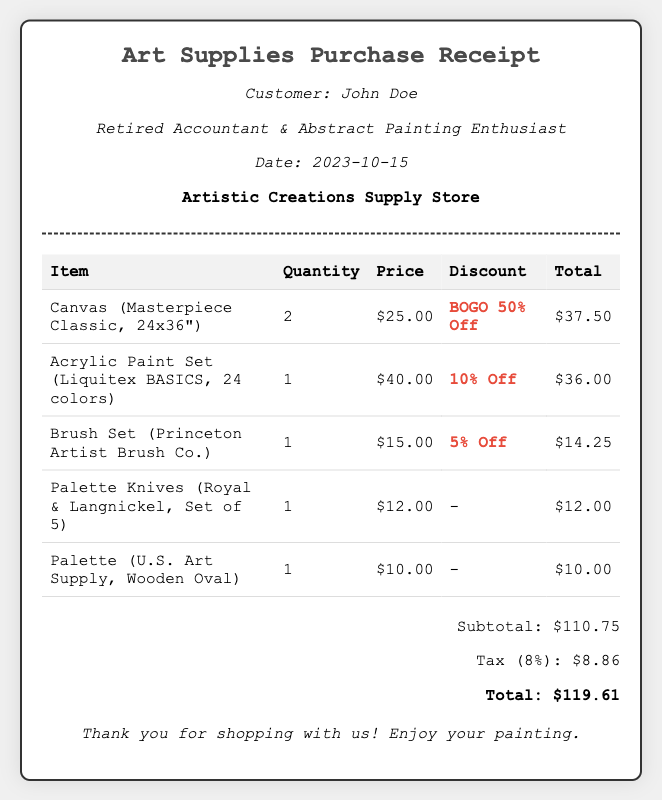What is the date of purchase? The date of purchase is stated in the document, which is 2023-10-15.
Answer: 2023-10-15 Who is the customer? The customer name is directly mentioned in the receipt, which is John Doe.
Answer: John Doe What was the price of the acrylic paint set? The price for the acrylic paint set is listed in the document, which is $40.00.
Answer: $40.00 What discount was applied to the canvas? The discount for the canvas is specified in the receipt as BOGO 50% Off.
Answer: BOGO 50% Off What is the subtotal amount before tax? The subtotal is calculated as the total amount before adding tax, which is $110.75.
Answer: $110.75 How many palette knives were purchased? The quantity of palette knives is noted in the receipt, which is 1.
Answer: 1 What is the total amount including tax? The total amount including tax is the sum of the subtotal and tax as detailed in the document, which is $119.61.
Answer: $119.61 Which item received a 10% discount? The item that received a 10% discount is specified in the document as the acrylic paint set.
Answer: Acrylic Paint Set What store issued the receipt? The store's name where the purchase was made is mentioned, which is Artistic Creations Supply Store.
Answer: Artistic Creations Supply Store 